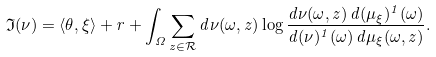<formula> <loc_0><loc_0><loc_500><loc_500>\mathfrak { I } ( \nu ) = \langle \theta , \xi \rangle + r + \int _ { \Omega } \sum _ { z \in \mathcal { R } } d \nu ( \omega , z ) \log \frac { d \nu ( \omega , z ) \, d ( \mu _ { \xi } ) ^ { 1 } ( \omega ) } { d ( \nu ) ^ { 1 } ( \omega ) \, d \mu _ { \xi } ( \omega , z ) } .</formula> 